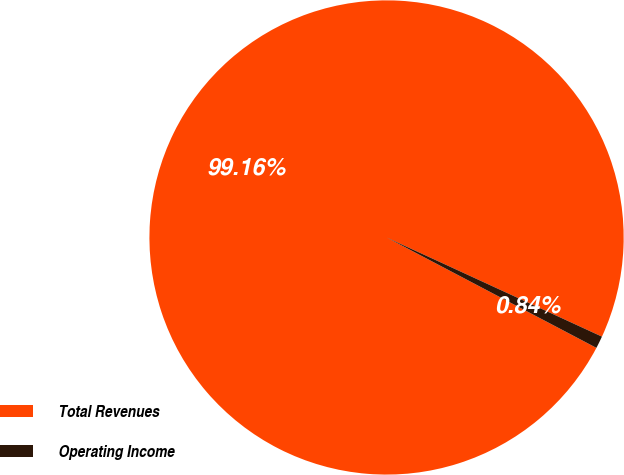Convert chart. <chart><loc_0><loc_0><loc_500><loc_500><pie_chart><fcel>Total Revenues<fcel>Operating Income<nl><fcel>99.16%<fcel>0.84%<nl></chart> 